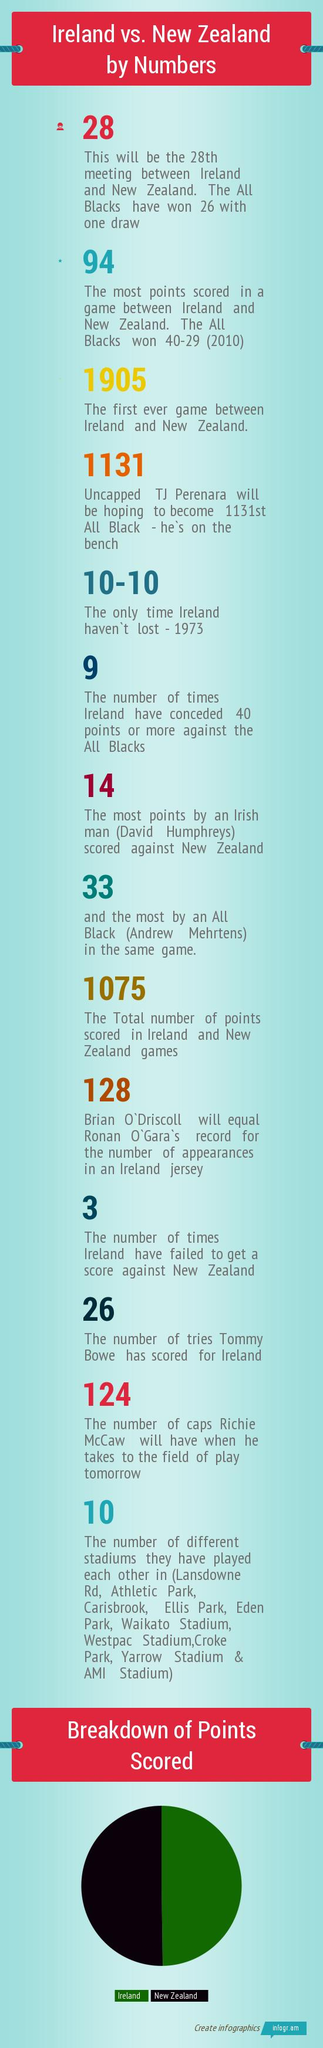Mention a couple of crucial points in this snapshot. David Humphrey was from Ireland. Brian O'Driscoll belongs to Ireland. The All Blacks have lost only one game in their entire history. The All Blacks scored 40 points in 2010. Other stadiums named "Park" include Athletic Park, Ellis Park, and Eden Park, excluding Croke Park. 